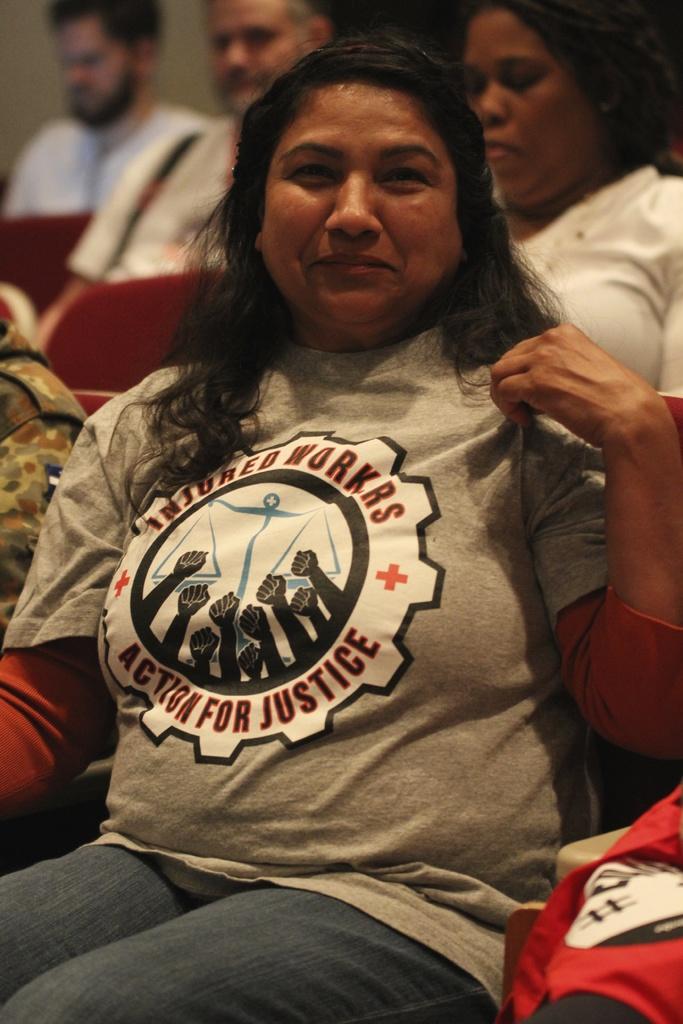What kind of union is that?
Keep it short and to the point. Injured workers. What is on the ladies shirt?
Ensure brevity in your answer.  Injured workers action for justice. 